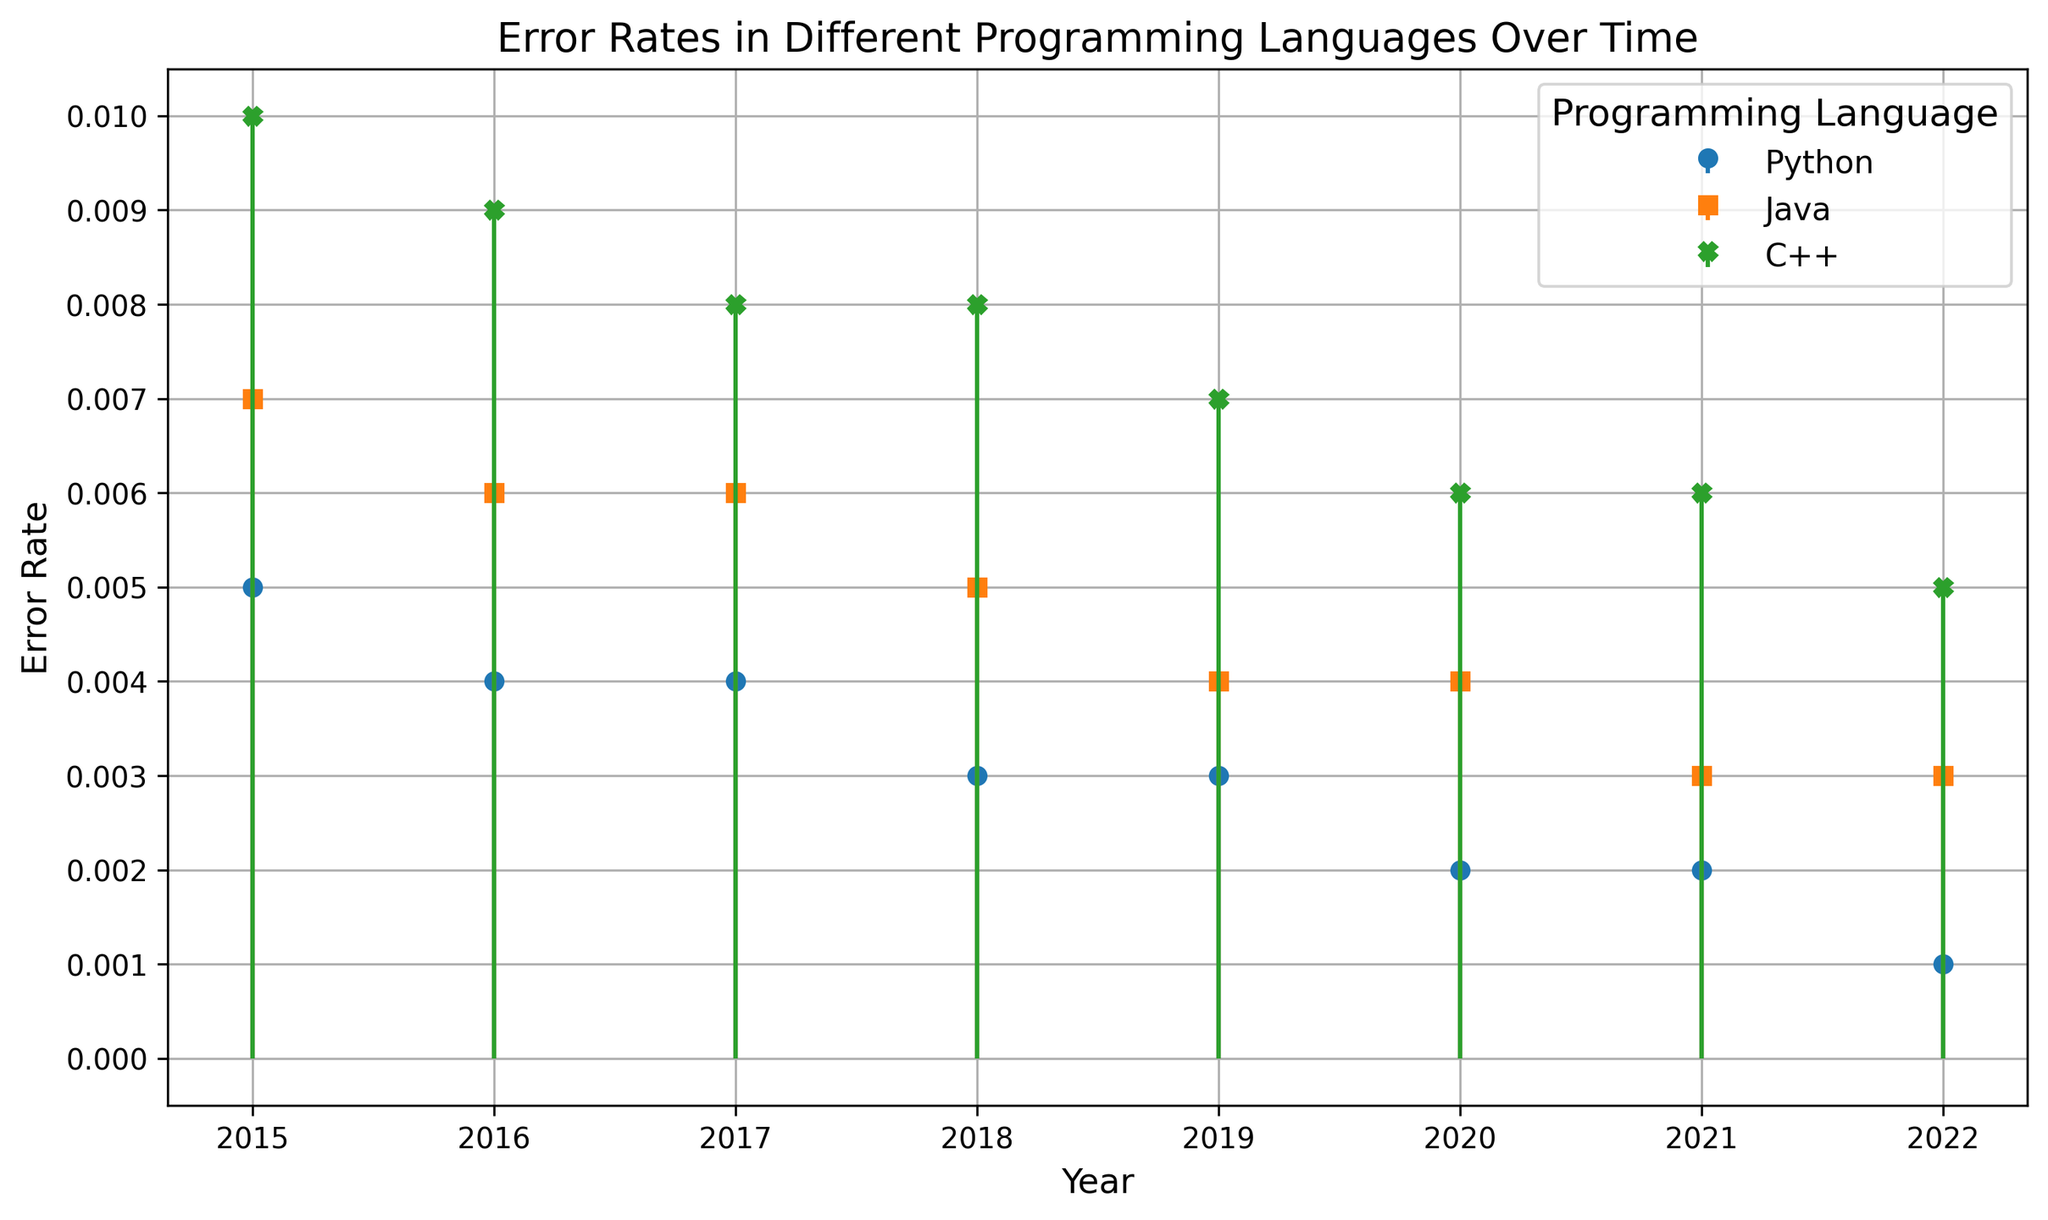What is the error rate of Python in 2020? First, locate the Python dataset, then find the value for the year 2020. The stem plot marker on the graph should show the value corresponding to Python for 2020.
Answer: 0.002 How did the error rate of C++ change from 2015 to 2022? Compare the heights of the stems corresponding to C++ between 2015 and 2022. In 2015, the error rate is at 0.010, while in 2022 it's at 0.005.
Answer: It decreased by 0.005 Which programming language had the highest error rate in 2017? Look at the year 2017 on the x-axis and compare the heights of the stems for each programming language. Java and C++ both have higher rates than Python in 2017. C++'s stem is taller than Java's.
Answer: C++ Compare the error rates of Python and Java in 2019. Which one is lower? Observe the stems for Python and Java in the year 2019. The height of Python's stem is shorter than Java's stem.
Answer: Python What is the average error rate of Java over the span of years shown in the figure? Find the error rates of Java for each year: 0.007, 0.006, 0.006, 0.005, 0.004, 0.004, 0.003, 0.003. Sum these values and divide by the number of years (8). Sum = 0.038. Average = 0.038/8 = 0.00475.
Answer: 0.00475 Compare the trends in error rates for Python and C++ from 2015 to 2022. Observe the direction and steepness of the slopes of Python and C++ stems over the years. Python’s error rate steadily decreases from 0.005 to 0.001. C++ shows an initial decrease from 2015 to 2019, then remains flat from 2019 to 2021, and finally slightly decreases in 2022.
Answer: Python consistently decreased, while C++ had a more fluctuating decrease Which year saw the largest decrease in error rate for Python? Compare the error rates for consecutive years for Python. The largest absolute decrease is noticeable between 2021 and 2022 (0.002 to 0.001).
Answer: 2022 What can be inferred about the trend lines for Java and C++ in 2018? By focusing on the year 2018 on the x-axis, notice the stems for Java and C++. Both exhibit a downward trend, as their error rates in 2018 are lower than in 2017.
Answer: Both decreased in 2018 What is the total error rate for Python from 2015 to 2022? Sum the yearly error rates for Python: 0.005 + 0.004 + 0.004 + 0.003 + 0.003 + 0.002 + 0.002 + 0.001. The total = 0.024.
Answer: 0.024 Between 2019 and 2020, did Java’s error rate see an increase, decrease, or remain the same? Compare the Java stems for 2019 and 2020 on the stem plot. Both values are equal at 0.004.
Answer: Remain the same 